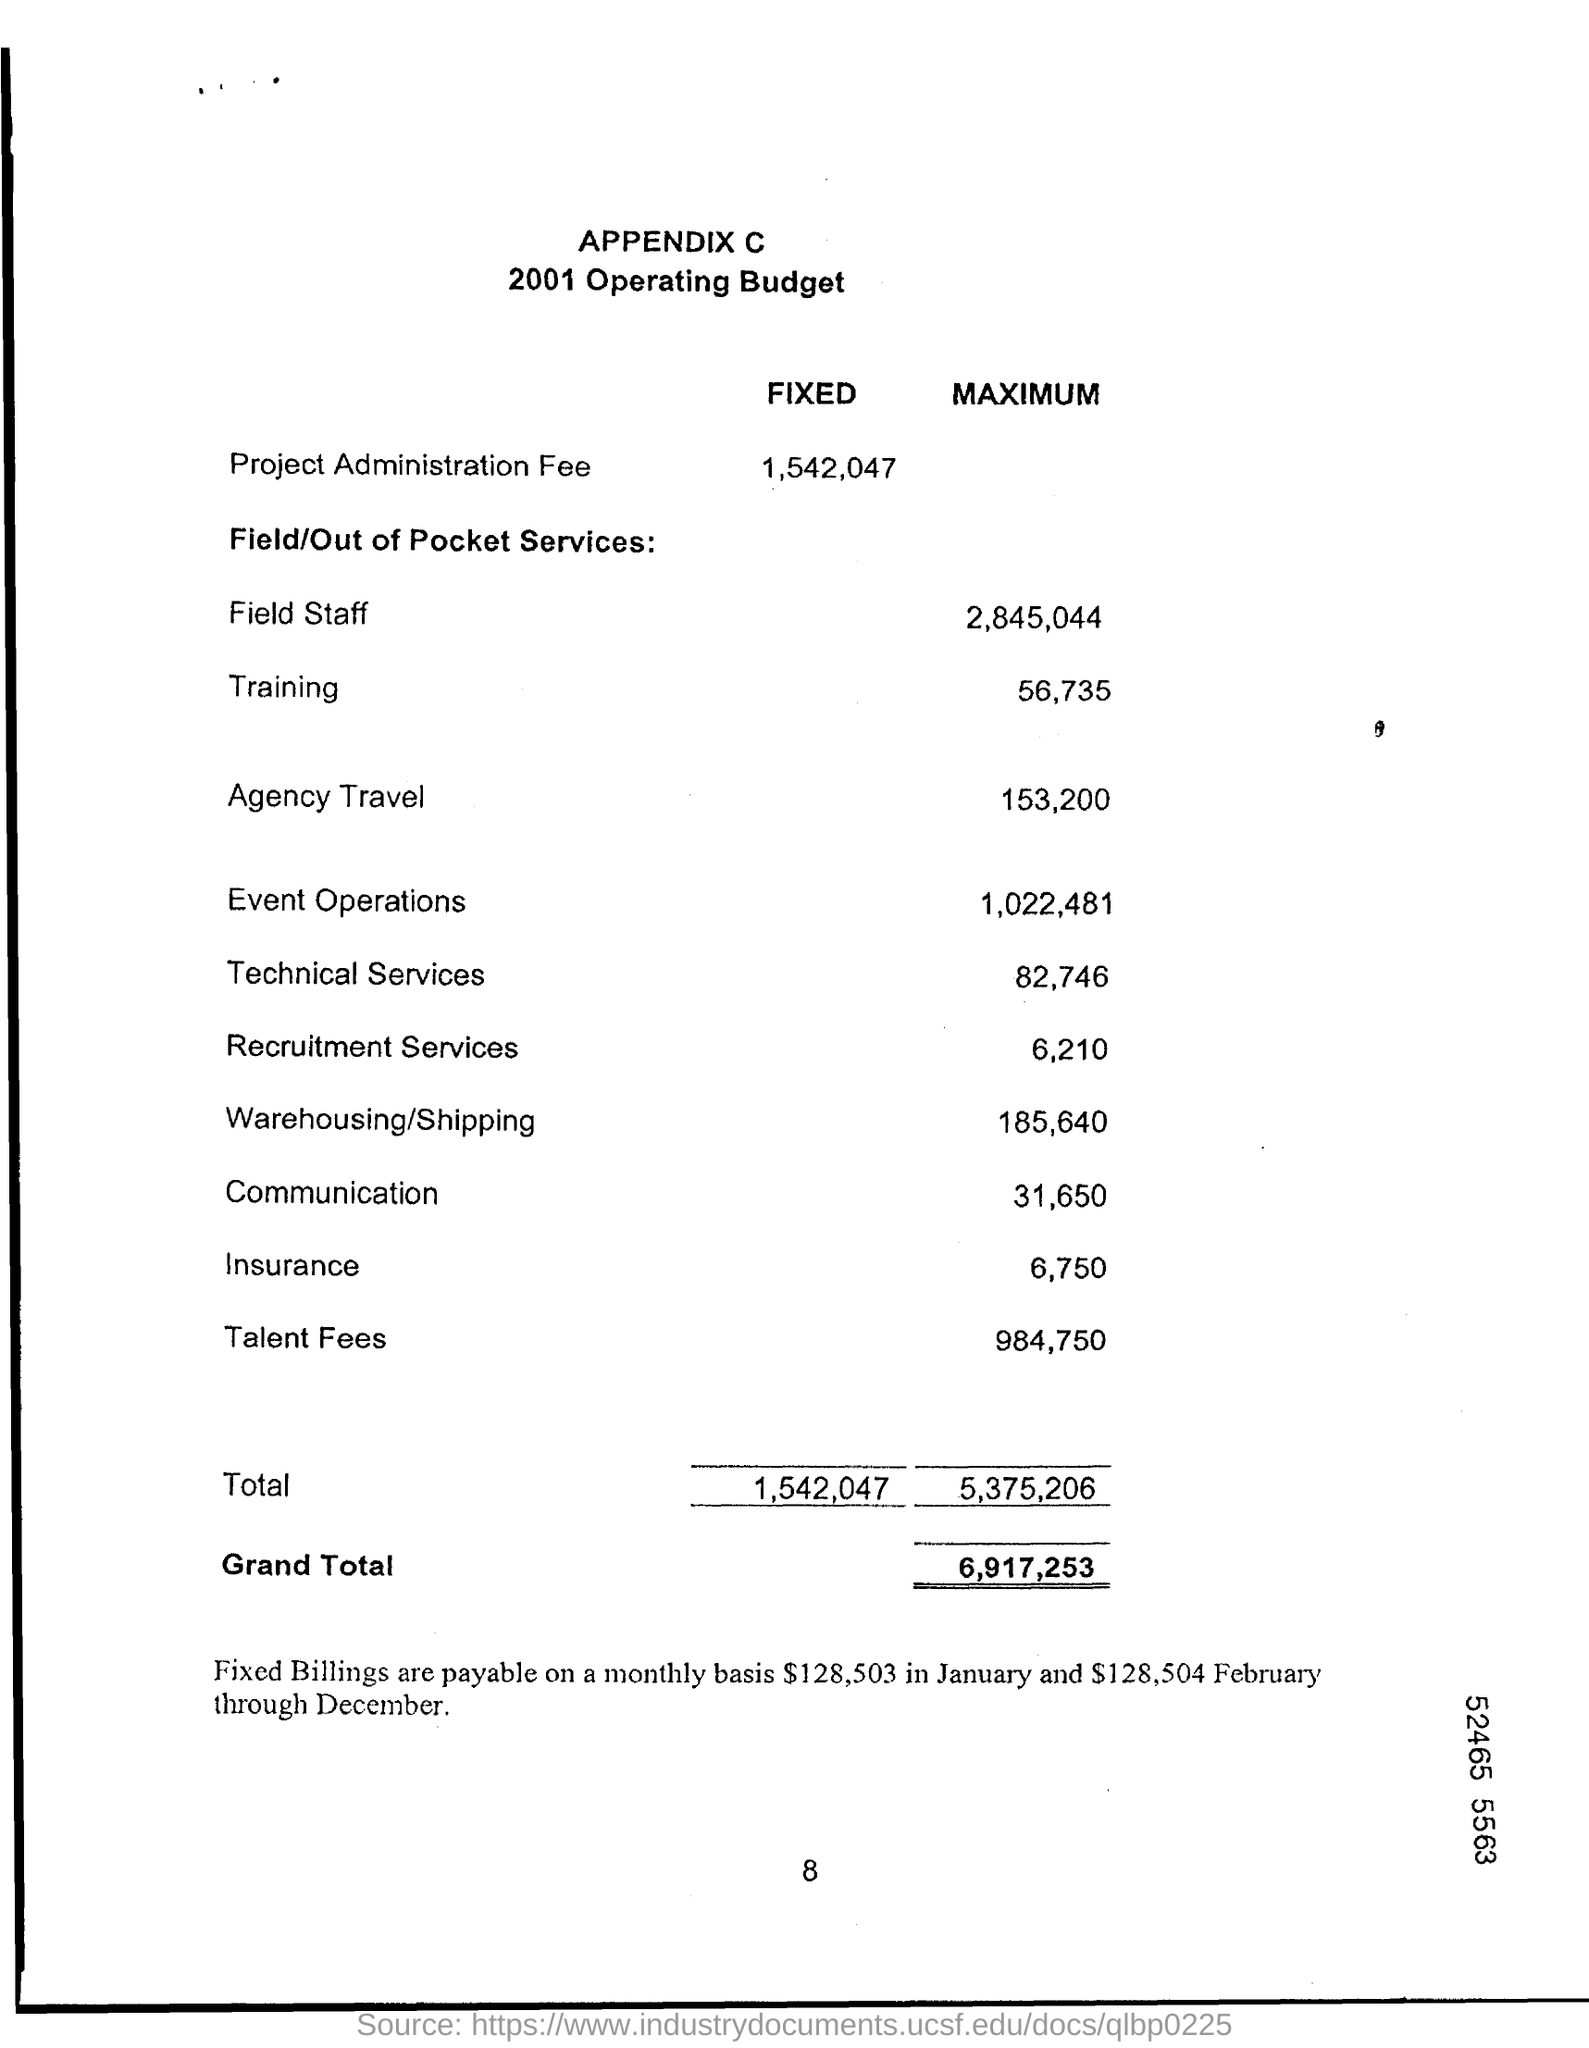What is the Fixed budget for Project Administration Fee?
Provide a succinct answer. 1,542,047. What is the "Maximum" budget for "Field staff"?
Your response must be concise. 2,845,044. What is the "Maximum" budget for "Communication"?
Ensure brevity in your answer.  31,650. What is the "Maximum" budget for "Insurance"?
Make the answer very short. 6,750. 